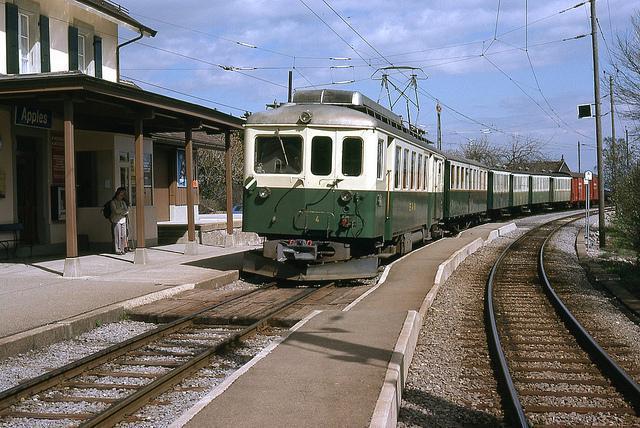What does this train primarily carry?
Indicate the correct choice and explain in the format: 'Answer: answer
Rationale: rationale.'
Options: Steel, coal, passengers, cars. Answer: passengers.
Rationale: It has windows along both sides and is stopping for the person waiting on the platform. 